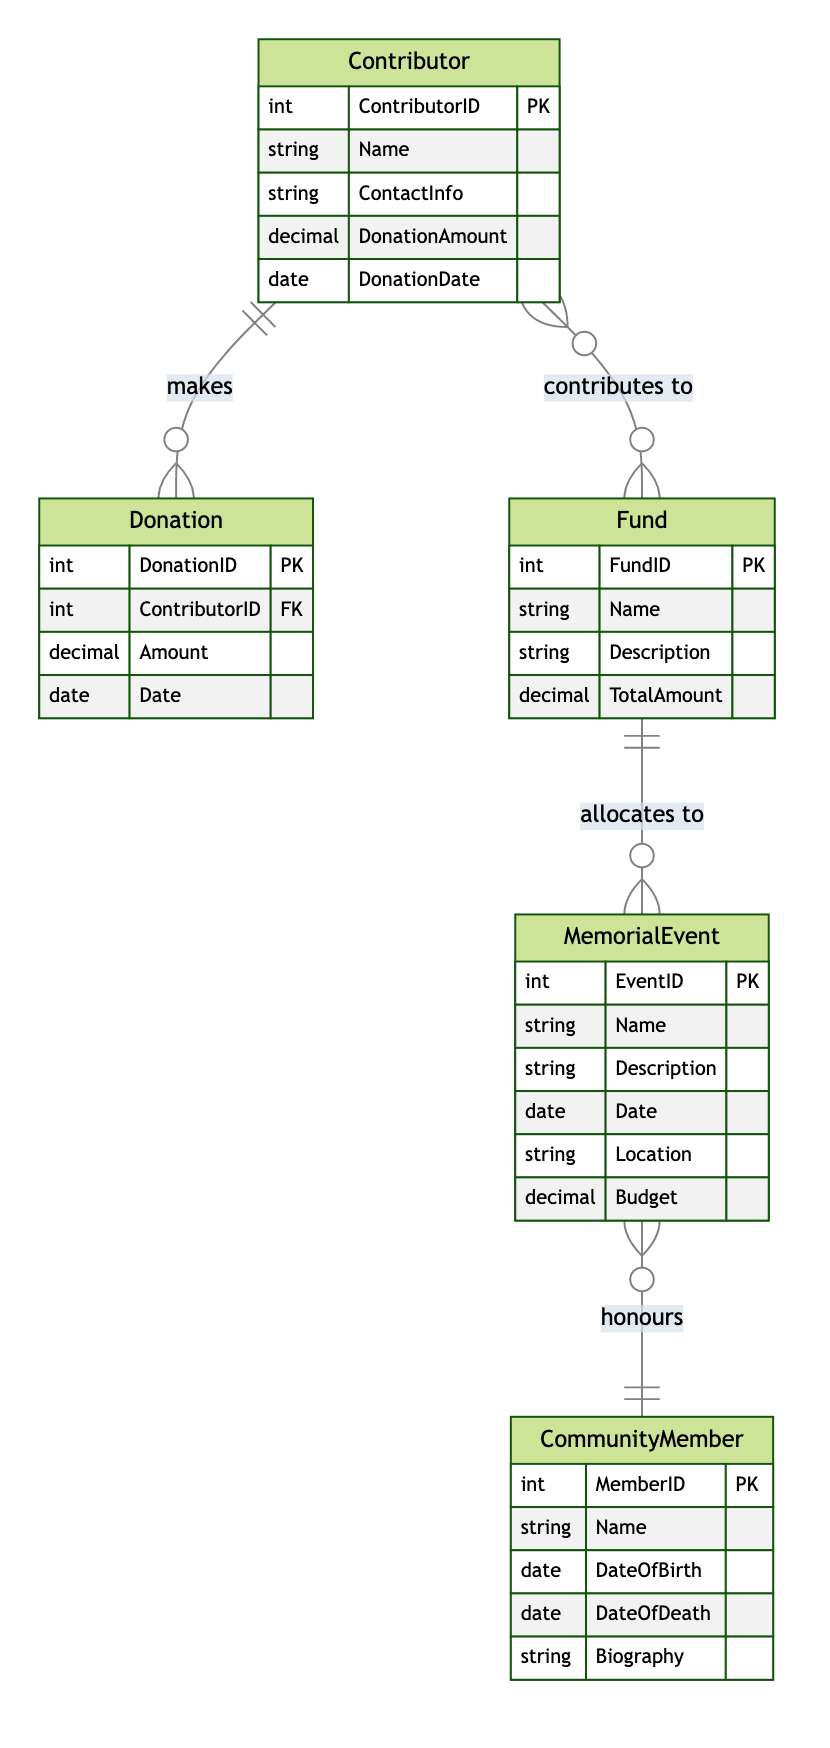What is the primary key of the Contributor entity? The primary key of the Contributor entity is ContributorID. This can be identified by looking at the entity definition in the diagram where it is indicated that ContributorID is denoted as PK (Primary Key).
Answer: ContributorID How many entities are present in the diagram? By counting the listed entities in the diagram, we can identify five distinct entities: Contributor, Donation, Fund, MemorialEvent, and CommunityMember. Therefore, the total number of entities is five.
Answer: 5 What is the relationship type between Contributor and Fund? The relationship between Contributor and Fund is labeled as "contributes to." It is noted that this relationship is of the Many-to-Many type, indicating contributors can contribute to multiple funds and each fund can be supported by multiple contributors.
Answer: Many-to-Many Which entity allocates funds to Memorial Events? The Fund entity allocates funds to Memorial Events. According to the relationship described in the diagram labeled "allocates to," it connects the Fund to MemorialEvent, stating the Fund is the entity that provides the financial resources for those events.
Answer: Fund What is the primary key of the MemorialEvent entity? The primary key of the MemorialEvent entity is EventID. This is indicated as PK within the MemorialEvent entity definition in the diagram, which identifies each memorial event uniquely.
Answer: EventID How many donations can a single contributor make? A single contributor can make multiple donations. This is inferred from the Many-to-One relationship where one Contributor can have multiple Donation records linked to their ContributorID, indicating that a single contributor may contribute many times.
Answer: Multiple What entity honors Community Members? MemorialEvent honors Community Members. This can be seen in the relationship named "honours" between the MemorialEvent and CommunityMember entities, indicating that each memorial event is dedicated to a specific community member.
Answer: MemorialEvent What attribute defines the total amount of money in a Fund? The TotalAmount attribute defines the total amount of money in a Fund. This is explicitly stated in the Fund entity attributes where TotalAmount is listed along with its data type.
Answer: TotalAmount How many ways can a Contributor contribute? A Contributor can contribute in one way, which is through the Donation. This is confirmed by the diagram which shows a direct relationship from Contributor to Donation, indicating that contributions are made in the form of donations.
Answer: One 